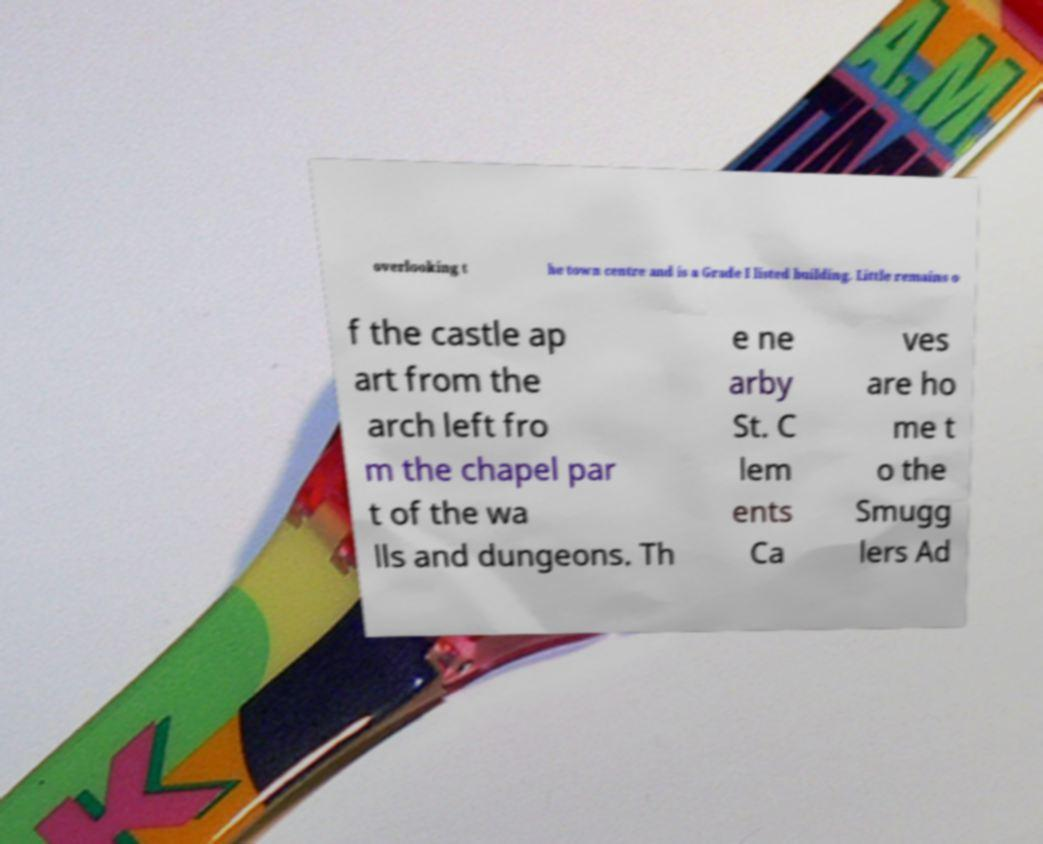I need the written content from this picture converted into text. Can you do that? overlooking t he town centre and is a Grade I listed building. Little remains o f the castle ap art from the arch left fro m the chapel par t of the wa lls and dungeons. Th e ne arby St. C lem ents Ca ves are ho me t o the Smugg lers Ad 